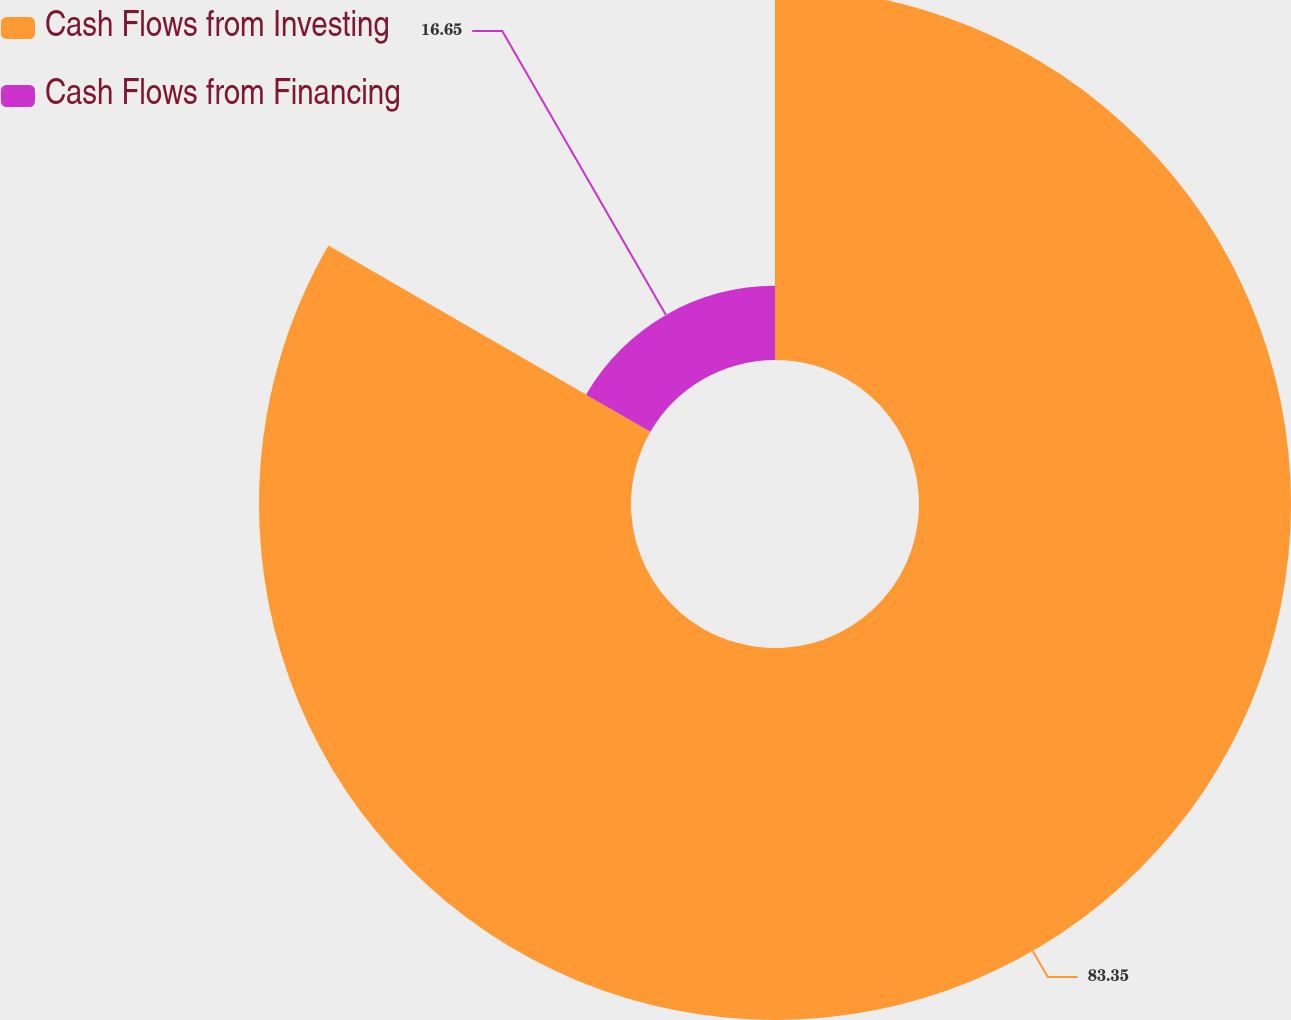Convert chart. <chart><loc_0><loc_0><loc_500><loc_500><pie_chart><fcel>Cash Flows from Investing<fcel>Cash Flows from Financing<nl><fcel>83.35%<fcel>16.65%<nl></chart> 